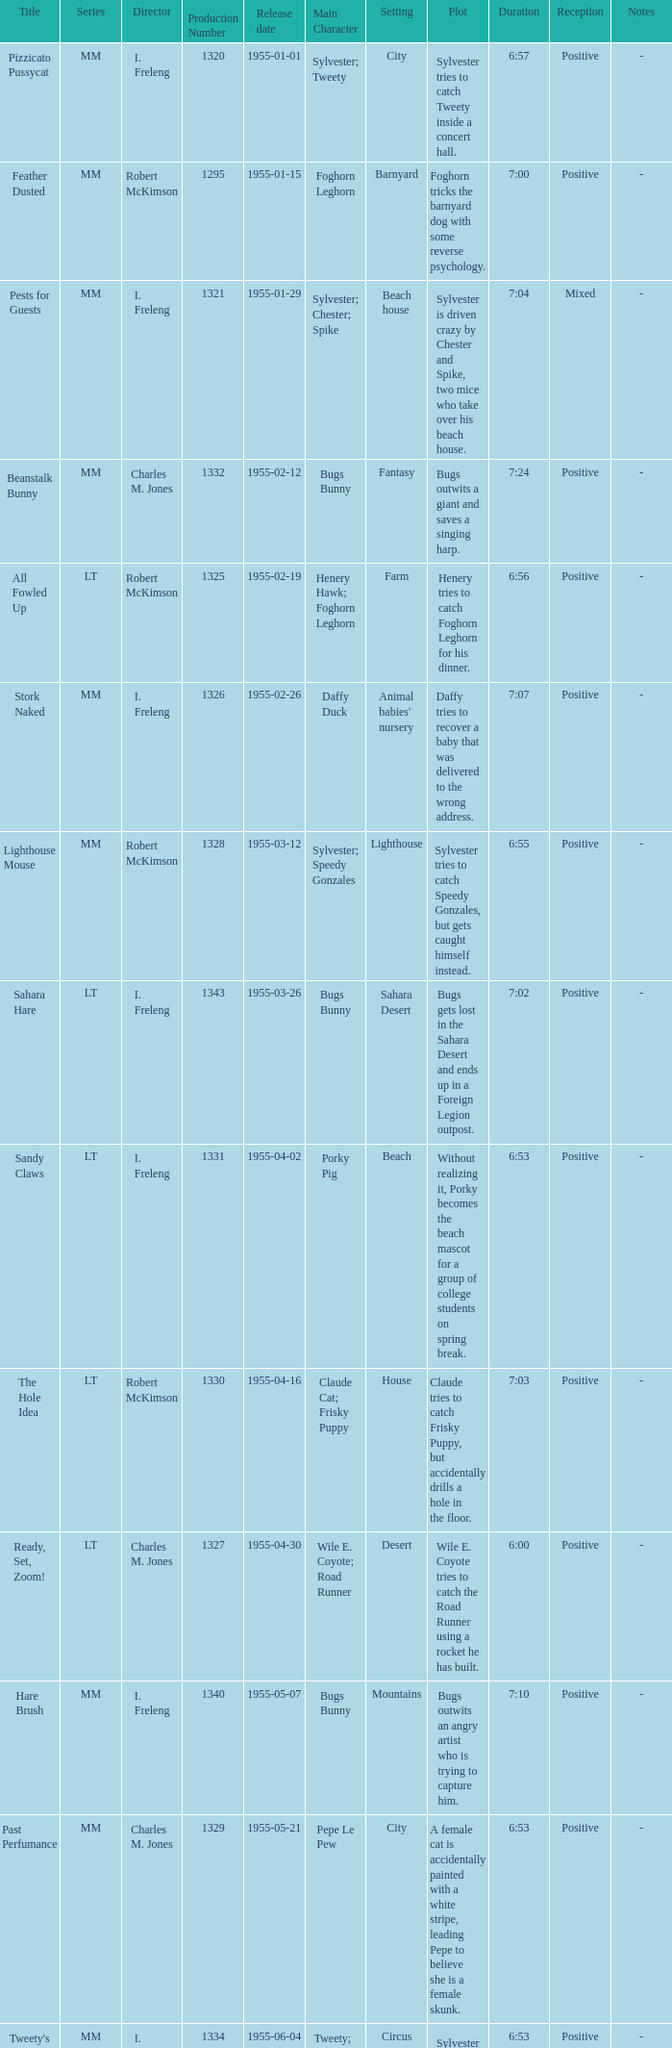What is the highest production number released on 1955-04-02 with i. freleng as the director? 1331.0. 